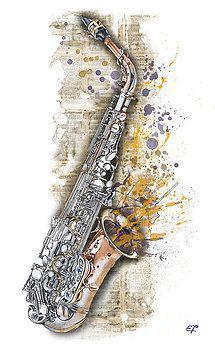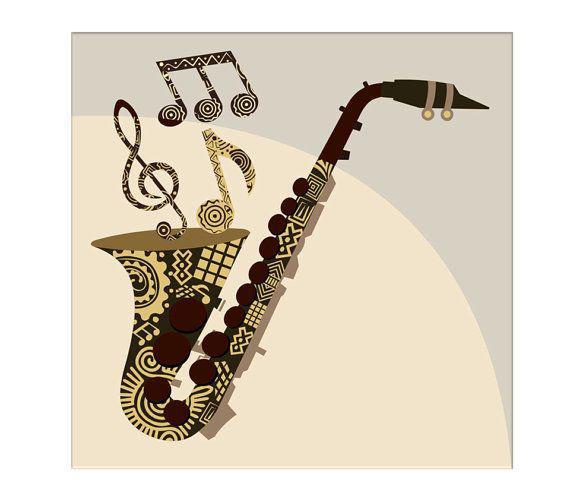The first image is the image on the left, the second image is the image on the right. Analyze the images presented: Is the assertion "The sax in the left image is pointed left and the sax in the right image is pointed right." valid? Answer yes or no. No. The first image is the image on the left, the second image is the image on the right. Assess this claim about the two images: "In at least one image there is a single saxophone surrounded by purple special dots.". Correct or not? Answer yes or no. Yes. 